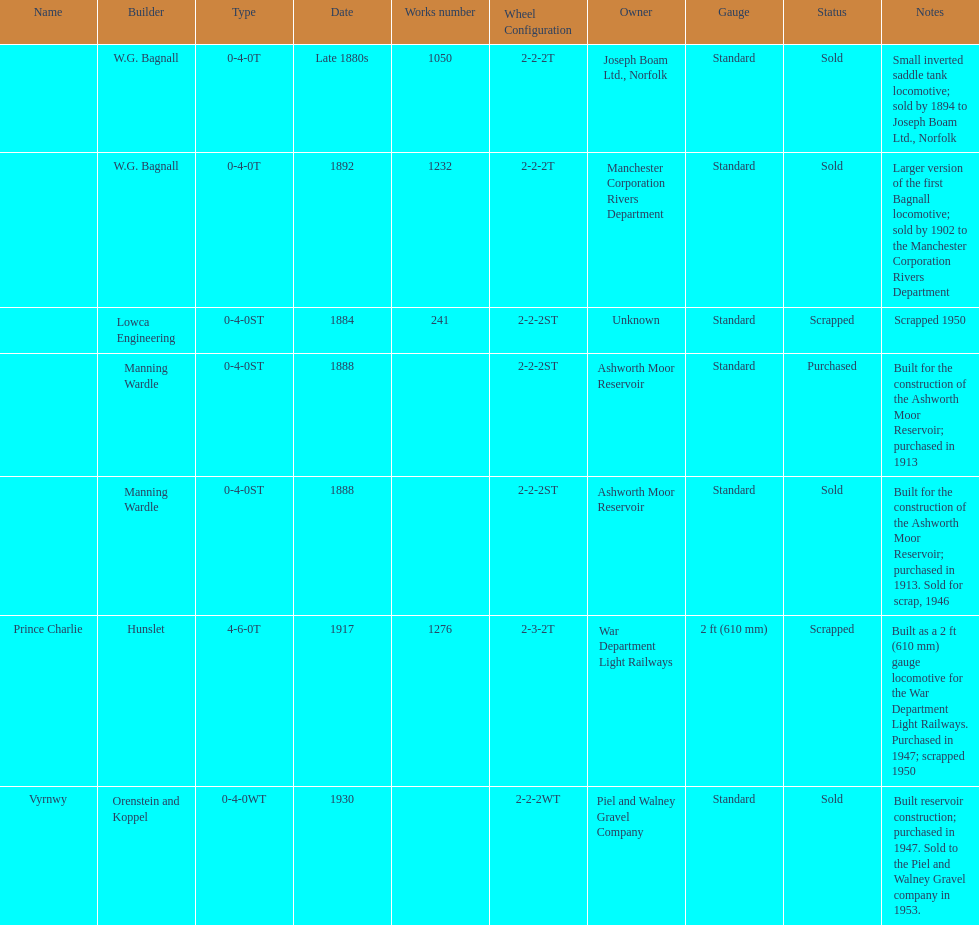How many locomotives were built after 1900? 2. 